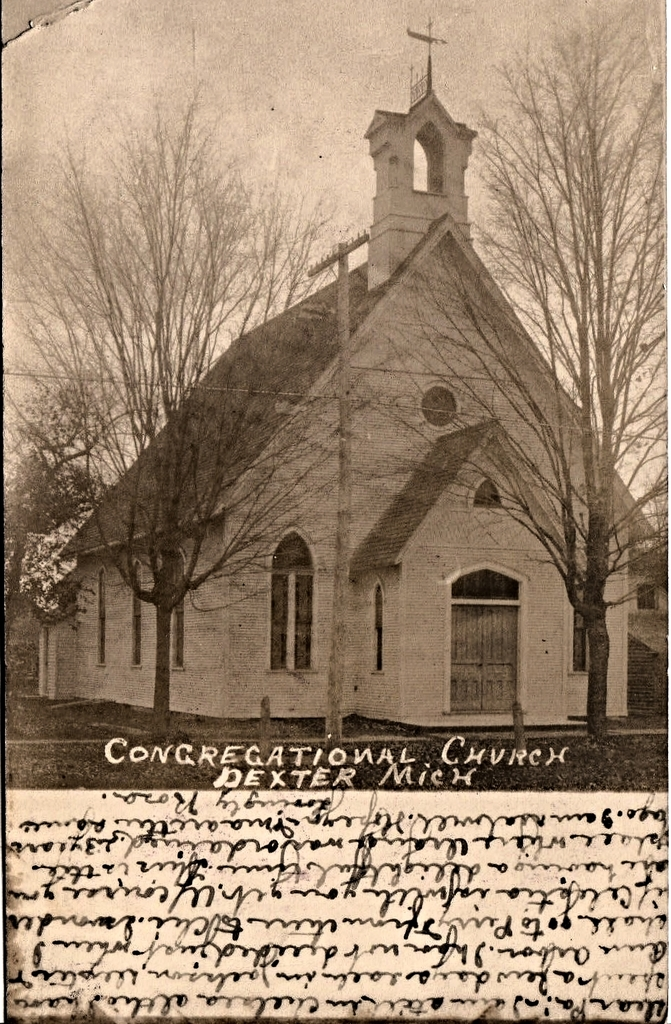What historical events might have taken place at this church given its old architecture? The church, with its historic Gothic Revival style, likely hosted numerous community gatherings, religious ceremonies, and possibly pivotal town meetings, reflecting the social and cultural hub it represented during its time. 